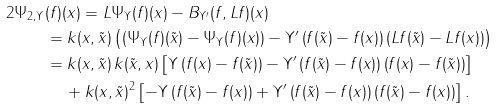Convert formula to latex. <formula><loc_0><loc_0><loc_500><loc_500>2 \Psi _ { 2 , \Upsilon } & ( f ) ( x ) = L \Psi _ { \Upsilon } ( f ) ( x ) - B _ { \Upsilon ^ { \prime } } ( f , L f ) ( x ) \\ & = k ( x , \tilde { x } ) \left ( \left ( \Psi _ { \Upsilon } ( f ) ( \tilde { x } ) - \Psi _ { \Upsilon } ( f ) ( x ) \right ) - \Upsilon ^ { \prime } \left ( f ( \tilde { x } ) - f ( x ) \right ) \left ( L f ( \tilde { x } ) - L f ( x ) \right ) \right ) \\ & = k ( x , \tilde { x } ) \, k ( \tilde { x } , x ) \left [ \Upsilon \left ( f ( x ) - f ( \tilde { x } ) \right ) - \Upsilon ^ { \prime } \left ( f ( \tilde { x } ) - f ( x ) \right ) \left ( f ( x ) - f ( \tilde { x } ) \right ) \right ] \\ & \, \quad + k ( x , \tilde { x } ) ^ { 2 } \left [ - \Upsilon \left ( f ( \tilde { x } ) - f ( x ) \right ) + \Upsilon ^ { \prime } \left ( f ( \tilde { x } ) - f ( x ) \right ) \left ( f ( \tilde { x } ) - f ( x ) \right ) \right ] .</formula> 